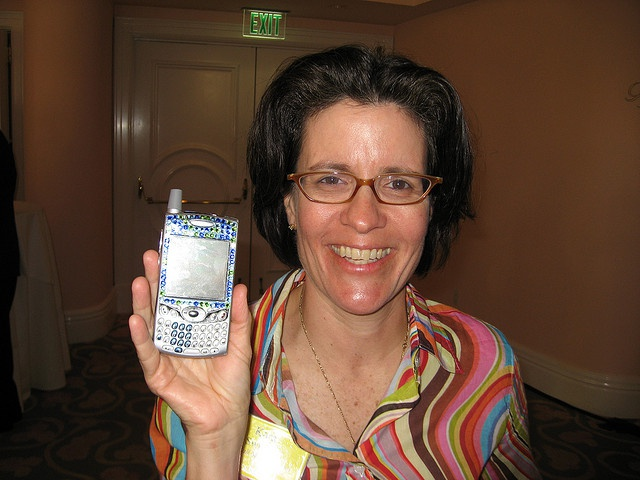Describe the objects in this image and their specific colors. I can see people in black, brown, and tan tones and cell phone in black, white, darkgray, gray, and lightblue tones in this image. 